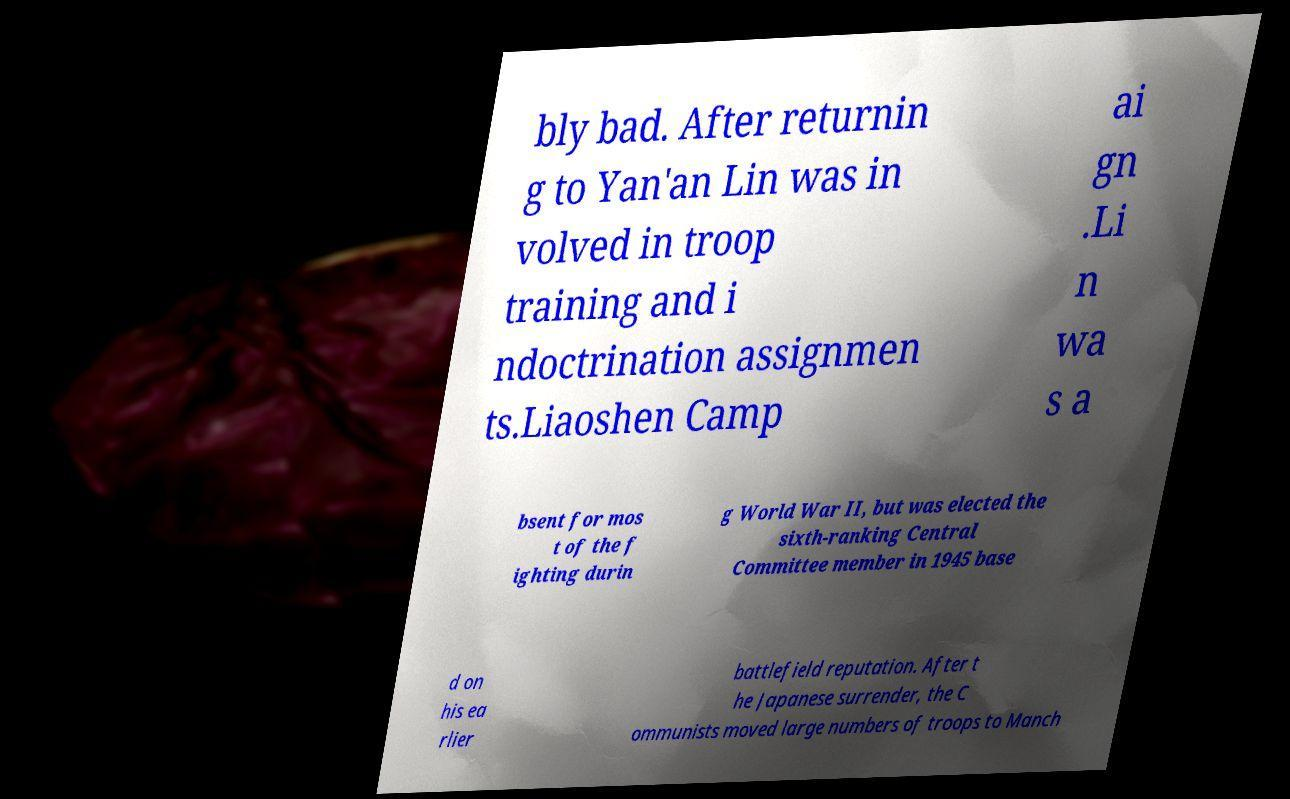There's text embedded in this image that I need extracted. Can you transcribe it verbatim? bly bad. After returnin g to Yan'an Lin was in volved in troop training and i ndoctrination assignmen ts.Liaoshen Camp ai gn .Li n wa s a bsent for mos t of the f ighting durin g World War II, but was elected the sixth-ranking Central Committee member in 1945 base d on his ea rlier battlefield reputation. After t he Japanese surrender, the C ommunists moved large numbers of troops to Manch 